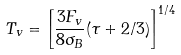<formula> <loc_0><loc_0><loc_500><loc_500>T _ { v } = \left [ \frac { 3 F _ { v } } { 8 \sigma _ { B } } ( \tau + 2 / 3 ) \right ] ^ { 1 / 4 }</formula> 